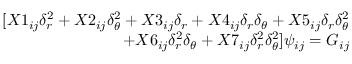Convert formula to latex. <formula><loc_0><loc_0><loc_500><loc_500>\begin{array} { r } { [ X 1 _ { i j } \delta _ { r } ^ { 2 } + X 2 _ { i j } \delta _ { \theta } ^ { 2 } + X 3 _ { i j } \delta _ { r } + X 4 _ { i j } \delta _ { r } \delta _ { \theta } + X 5 _ { i j } \delta _ { r } \delta _ { \theta } ^ { 2 } } \\ { + X 6 _ { i j } \delta _ { r } ^ { 2 } \delta _ { \theta } + X 7 _ { i j } \delta _ { r } ^ { 2 } \delta _ { \theta } ^ { 2 } ] \psi _ { i j } = G _ { i j } } \end{array}</formula> 